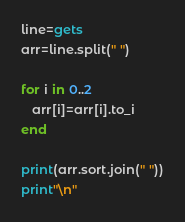Convert code to text. <code><loc_0><loc_0><loc_500><loc_500><_Ruby_>line=gets
arr=line.split(" ")

for i in 0..2
   arr[i]=arr[i].to_i
end

print(arr.sort.join(" "))
print"\n"</code> 